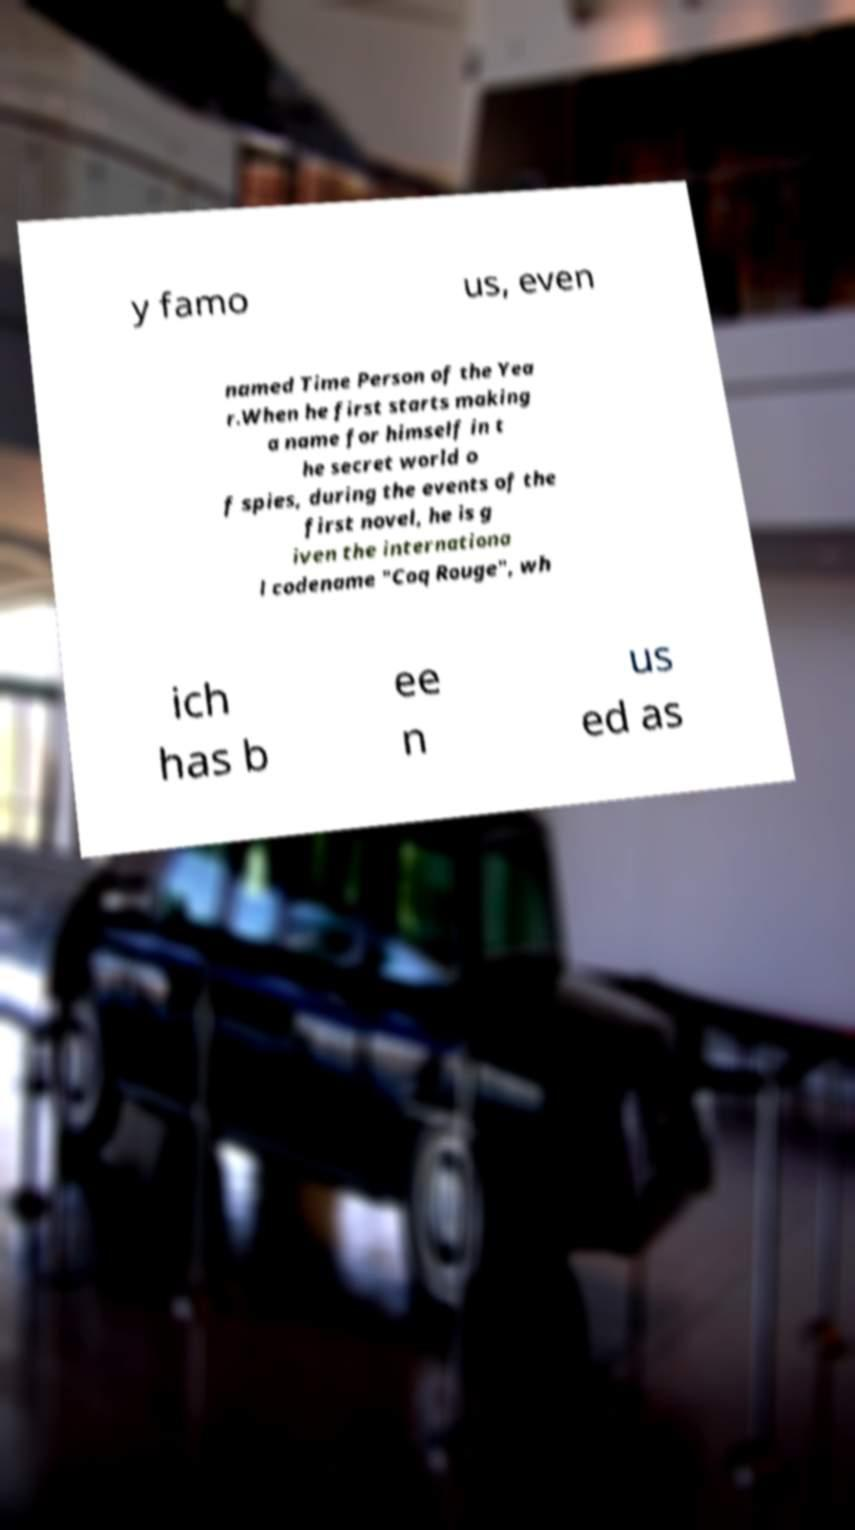Can you accurately transcribe the text from the provided image for me? y famo us, even named Time Person of the Yea r.When he first starts making a name for himself in t he secret world o f spies, during the events of the first novel, he is g iven the internationa l codename "Coq Rouge", wh ich has b ee n us ed as 